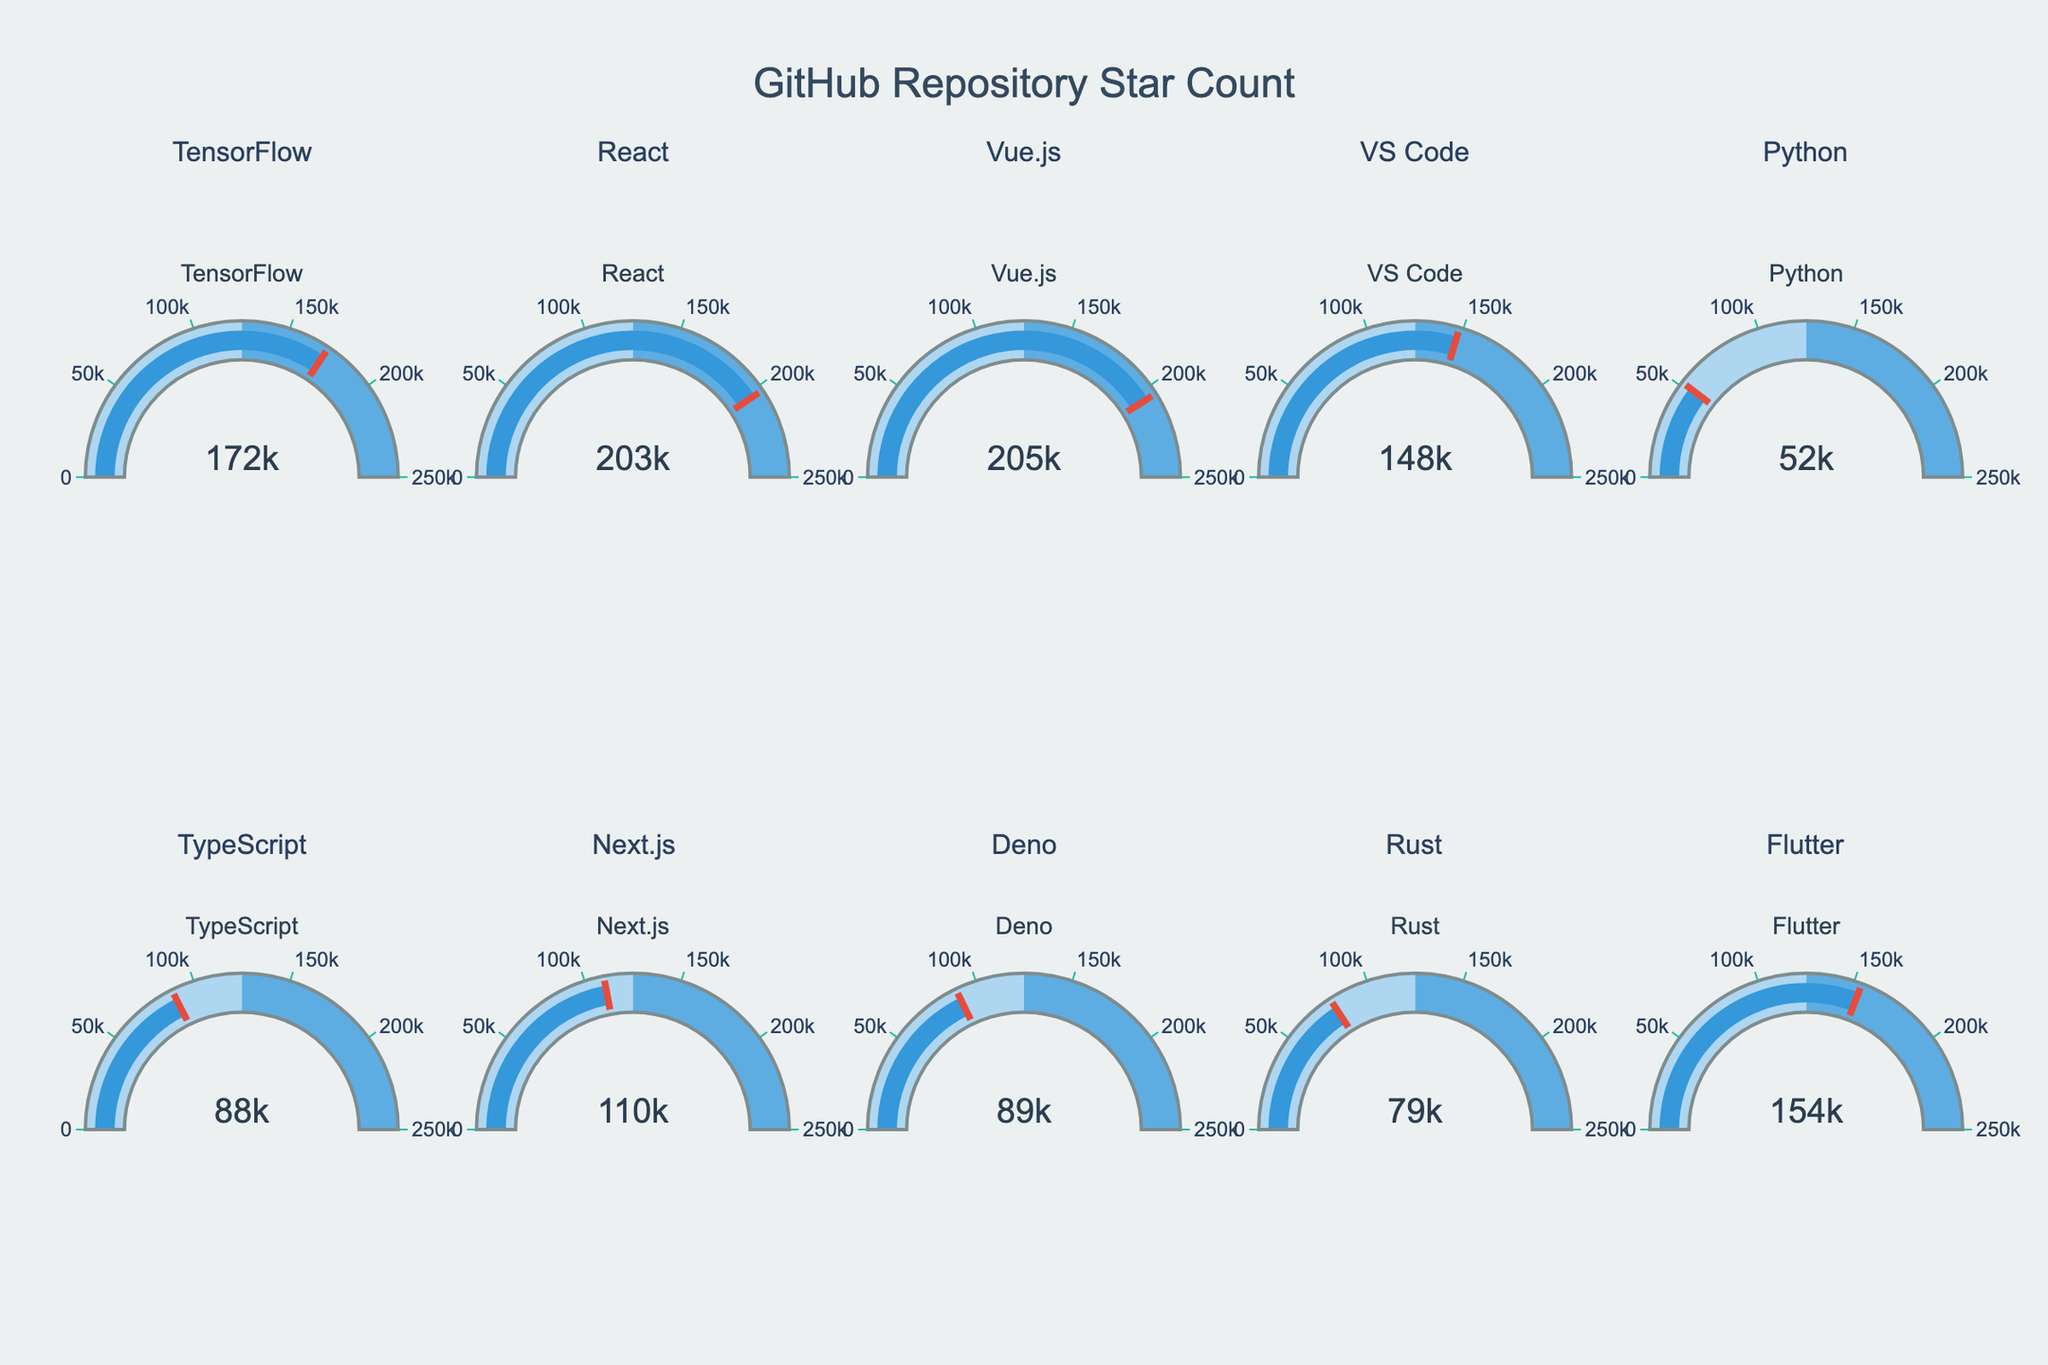Which repository has the highest star count? To determine which repository has the highest star count, look at the gauge with the highest value. The "Vue.js" repository has a star count of 205,000, which is the highest among all shown gauges.
Answer: Vue.js What's the difference in star count between "React" and "TensorFlow"? Identify the star counts for "React" (203,000) and "TensorFlow" (172,000) from their respective gauges. Subtract the star count of TensorFlow from React's. The calculation is 203,000 - 172,000 = 31,000.
Answer: 31,000 How many repositories have a star count greater than 100,000? Count the number of gauges with values exceeding 100,000. The repositories that exceed 100,000 stars are "React," "Vue.js," "VS Code," "Next.js," and "Flutter." There are 5 such repositories.
Answer: 5 What is the star count range displayed in the gauges? The gauges display star counts ranging from the smallest to the maximum star count in the data. The smallest star count is 52,000 (Python), and the maximum star count is 205,000 (Vue.js). Thus, the range is from 52,000 to 205,000.
Answer: 52,000 to 205,000 Which repositories have a star count close to the median value in the dataset? First, list the star counts: 52,000, 79,000, 88,000, 89,000, 110,000, 148,000, 154,000, 172,000, 203,000, 205,000. The median value, being the middle value in this sorted list, is the average of the 5th and 6th values: (110,000 + 148,000)/2 = 129,000. No repository has exactly 129,000 stars, but close candidates are "VS Code" (148,000) and "Next.js" (110,000).
Answer: VS Code, Next.js How does the star count of "TypeScript" compare to that of "Deno"? Look at the gauge for "TypeScript" which shows 88,000 and "Deno" which shows 89,000. "Deno" has a slightly higher star count than "TypeScript."
Answer: Deno Which repositories have a star count less than 100,000? Look at the gauges corresponding to star counts below 100,000. These repositories are "Python," "TypeScript," "Deno," and "Rust."
Answer: Python, TypeScript, Deno, Rust 